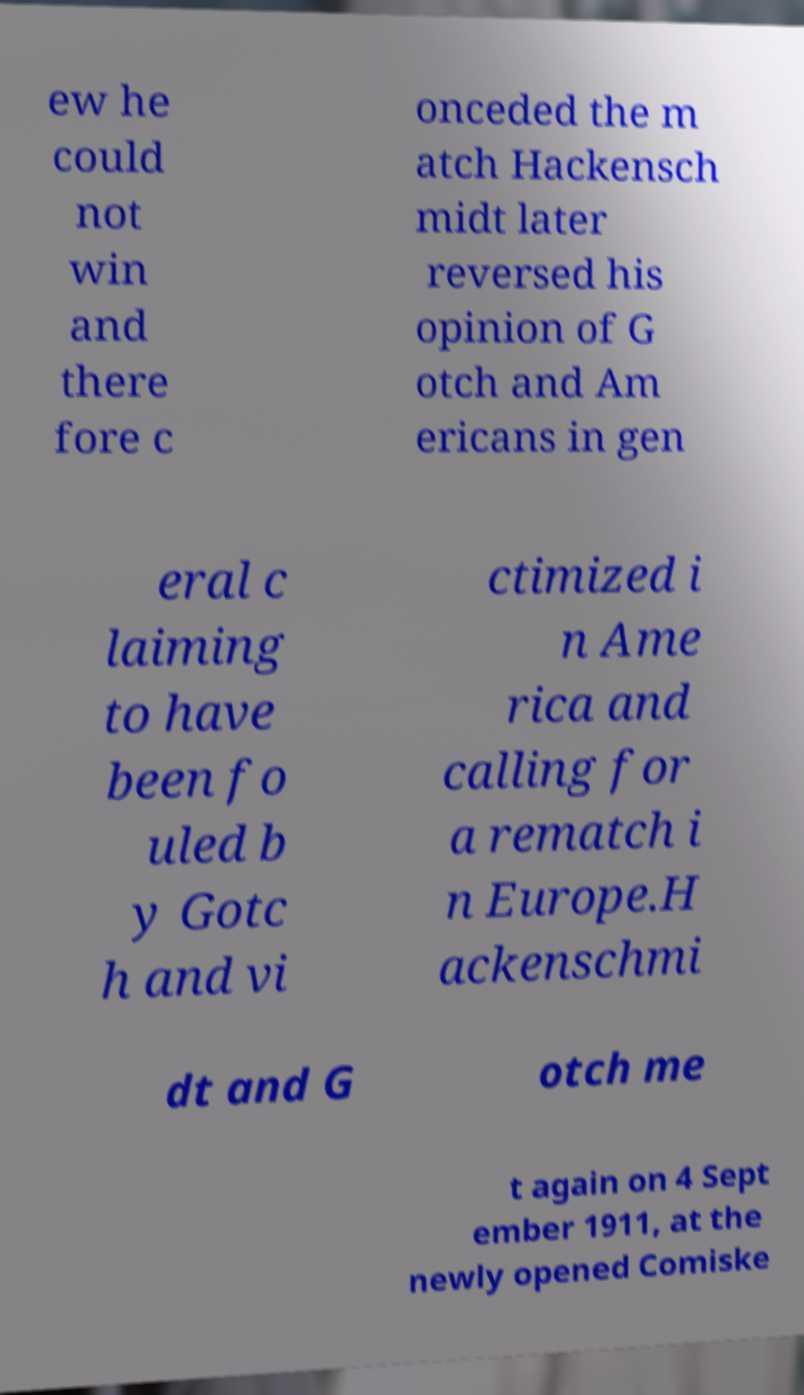There's text embedded in this image that I need extracted. Can you transcribe it verbatim? ew he could not win and there fore c onceded the m atch Hackensch midt later reversed his opinion of G otch and Am ericans in gen eral c laiming to have been fo uled b y Gotc h and vi ctimized i n Ame rica and calling for a rematch i n Europe.H ackenschmi dt and G otch me t again on 4 Sept ember 1911, at the newly opened Comiske 